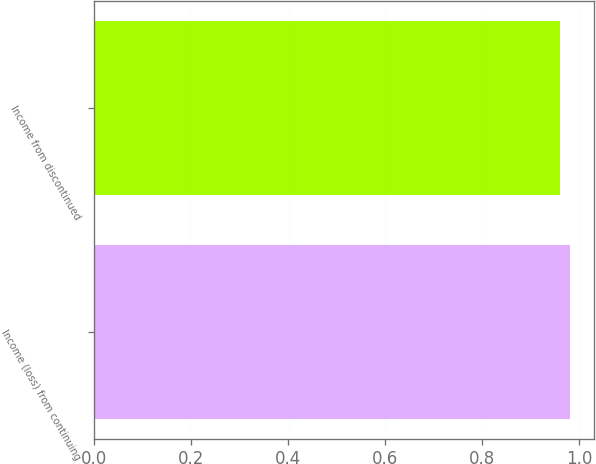Convert chart. <chart><loc_0><loc_0><loc_500><loc_500><bar_chart><fcel>Income (loss) from continuing<fcel>Income from discontinued<nl><fcel>0.98<fcel>0.96<nl></chart> 